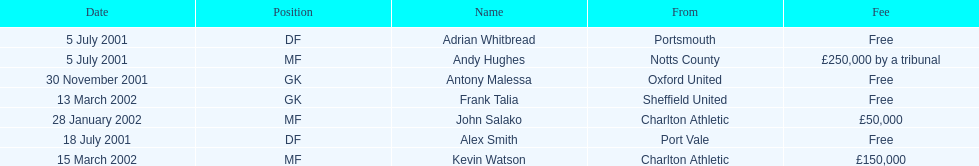Give me the full table as a dictionary. {'header': ['Date', 'Position', 'Name', 'From', 'Fee'], 'rows': [['5 July 2001', 'DF', 'Adrian Whitbread', 'Portsmouth', 'Free'], ['5 July 2001', 'MF', 'Andy Hughes', 'Notts County', '£250,000 by a tribunal'], ['30 November 2001', 'GK', 'Antony Malessa', 'Oxford United', 'Free'], ['13 March 2002', 'GK', 'Frank Talia', 'Sheffield United', 'Free'], ['28 January 2002', 'MF', 'John Salako', 'Charlton Athletic', '£50,000'], ['18 July 2001', 'DF', 'Alex Smith', 'Port Vale', 'Free'], ['15 March 2002', 'MF', 'Kevin Watson', 'Charlton Athletic', '£150,000']]} Which transfer in was next after john salako's in 2002? Frank Talia. 